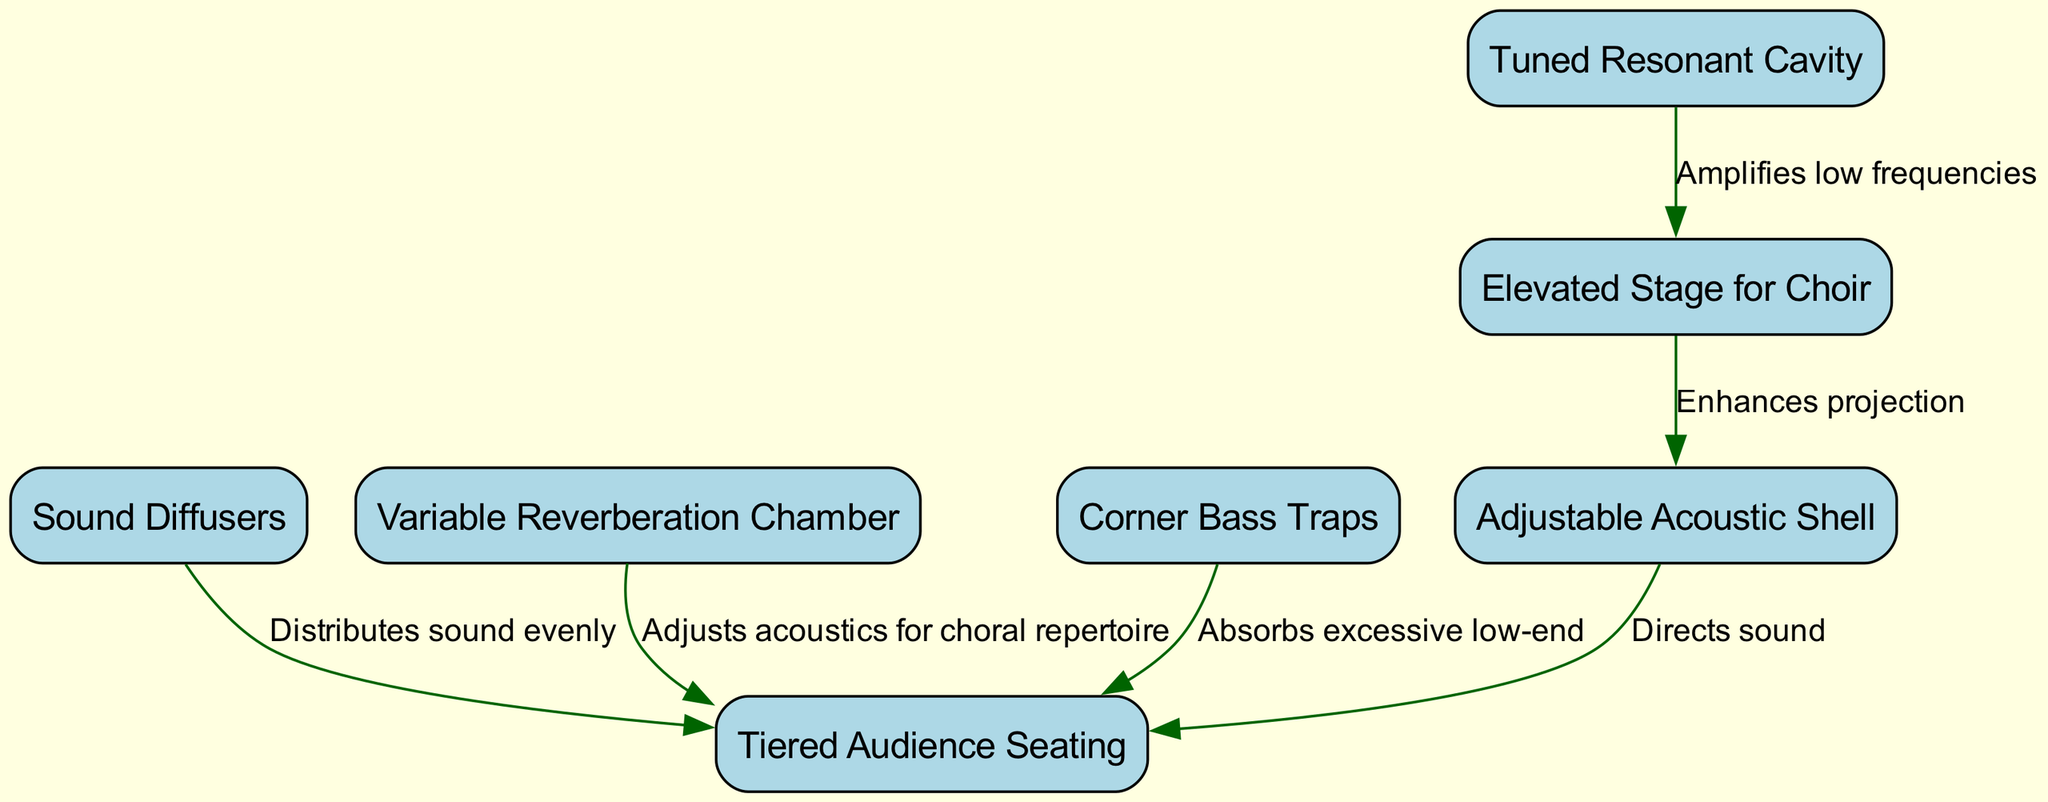What is the purpose of the elevated stage? The elevated stage is designed for the choir, allowing for better visibility and sound projection.
Answer: Elevated Stage for Choir How many nodes are in the diagram? By counting the individual elements listed in the nodes section of the data, we find there are a total of 7 nodes.
Answer: 7 What does the adjustable acoustic shell do? The adjustable acoustic shell enhances the projection of sound from the choir to the audience.
Answer: Enhances projection How does the sound diffusers affect the audience? The sound diffusers distribute sound evenly to the audience seating area, improving the sound experience for all listeners.
Answer: Distributes sound evenly What is the relationship between the resonant cavity and the stage? The resonant cavity amplifies low frequencies, impacting the sound perceived from the stage.
Answer: Amplifies low frequencies Which component adjusts acoustics for choral repertoire? The variable reverberation chamber is specifically responsible for adjusting acoustics to match the needs of the choral repertoire.
Answer: Variable Reverberation Chamber What is the function of the corner bass traps? Corner bass traps absorb excessive low-end frequencies that may otherwise impact the clarity of the sound in the audience area.
Answer: Absorbs excessive low-end How many edges connect the acoustic shell and audience seating? There is one edge connecting the acoustic shell to the audience seating, indicating a direct relationship.
Answer: 1 What two components directly enhance the sound experience for the audience? The sound diffusers and variable reverberation chamber both play a crucial role in enhancing the overall sound experience for the audience.
Answer: Sound Diffusers, Variable Reverberation Chamber 